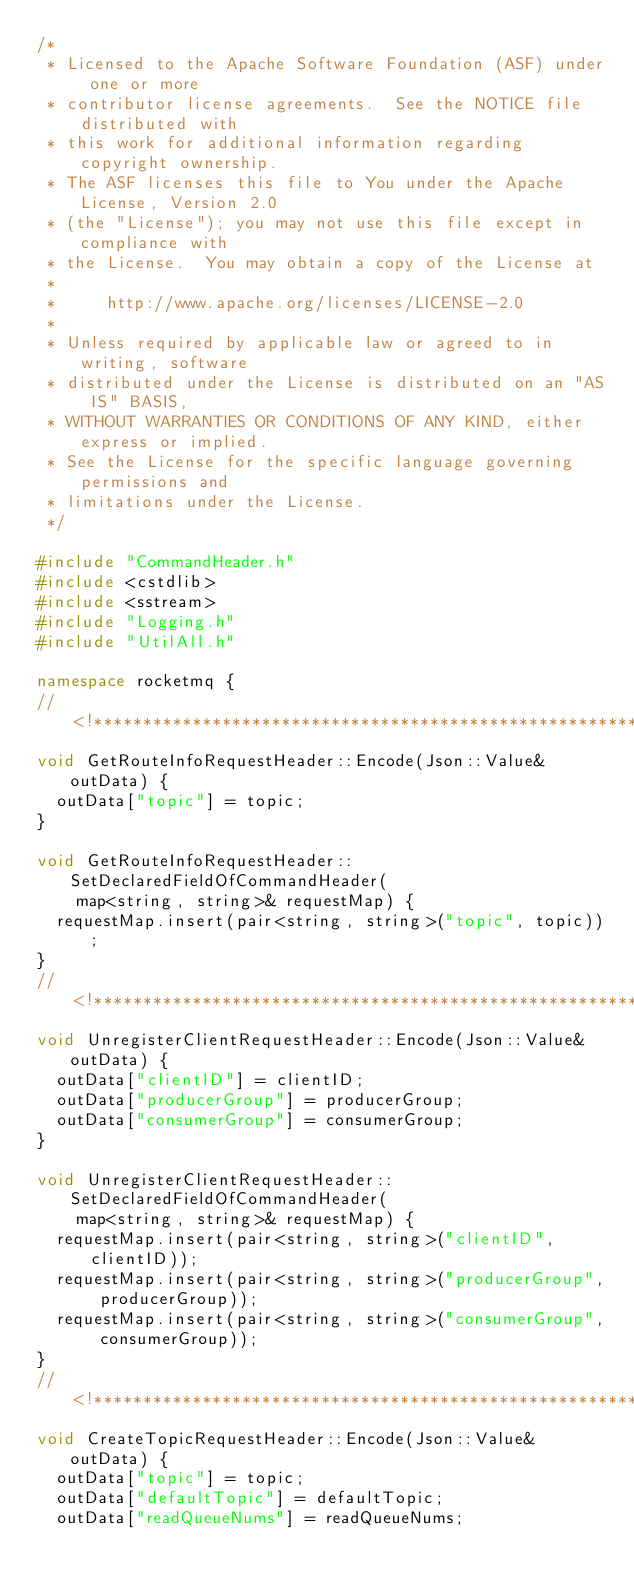Convert code to text. <code><loc_0><loc_0><loc_500><loc_500><_C++_>/*
 * Licensed to the Apache Software Foundation (ASF) under one or more
 * contributor license agreements.  See the NOTICE file distributed with
 * this work for additional information regarding copyright ownership.
 * The ASF licenses this file to You under the Apache License, Version 2.0
 * (the "License"); you may not use this file except in compliance with
 * the License.  You may obtain a copy of the License at
 *
 *     http://www.apache.org/licenses/LICENSE-2.0
 *
 * Unless required by applicable law or agreed to in writing, software
 * distributed under the License is distributed on an "AS IS" BASIS,
 * WITHOUT WARRANTIES OR CONDITIONS OF ANY KIND, either express or implied.
 * See the License for the specific language governing permissions and
 * limitations under the License.
 */

#include "CommandHeader.h"
#include <cstdlib>
#include <sstream>
#include "Logging.h"
#include "UtilAll.h"

namespace rocketmq {
//<!************************************************************************
void GetRouteInfoRequestHeader::Encode(Json::Value& outData) {
  outData["topic"] = topic;
}

void GetRouteInfoRequestHeader::SetDeclaredFieldOfCommandHeader(
    map<string, string>& requestMap) {
  requestMap.insert(pair<string, string>("topic", topic));
}
//<!***************************************************************************
void UnregisterClientRequestHeader::Encode(Json::Value& outData) {
  outData["clientID"] = clientID;
  outData["producerGroup"] = producerGroup;
  outData["consumerGroup"] = consumerGroup;
}

void UnregisterClientRequestHeader::SetDeclaredFieldOfCommandHeader(
    map<string, string>& requestMap) {
  requestMap.insert(pair<string, string>("clientID", clientID));
  requestMap.insert(pair<string, string>("producerGroup", producerGroup));
  requestMap.insert(pair<string, string>("consumerGroup", consumerGroup));
}
//<!************************************************************************
void CreateTopicRequestHeader::Encode(Json::Value& outData) {
  outData["topic"] = topic;
  outData["defaultTopic"] = defaultTopic;
  outData["readQueueNums"] = readQueueNums;</code> 